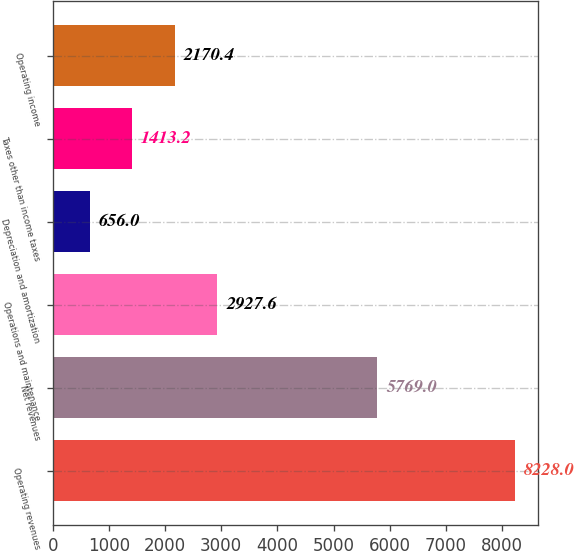Convert chart. <chart><loc_0><loc_0><loc_500><loc_500><bar_chart><fcel>Operating revenues<fcel>Net revenues<fcel>Operations and maintenance<fcel>Depreciation and amortization<fcel>Taxes other than income taxes<fcel>Operating income<nl><fcel>8228<fcel>5769<fcel>2927.6<fcel>656<fcel>1413.2<fcel>2170.4<nl></chart> 